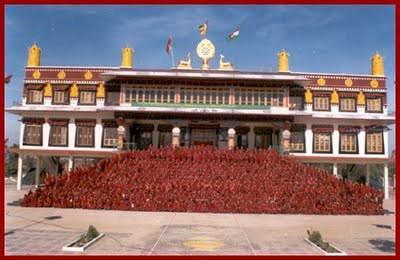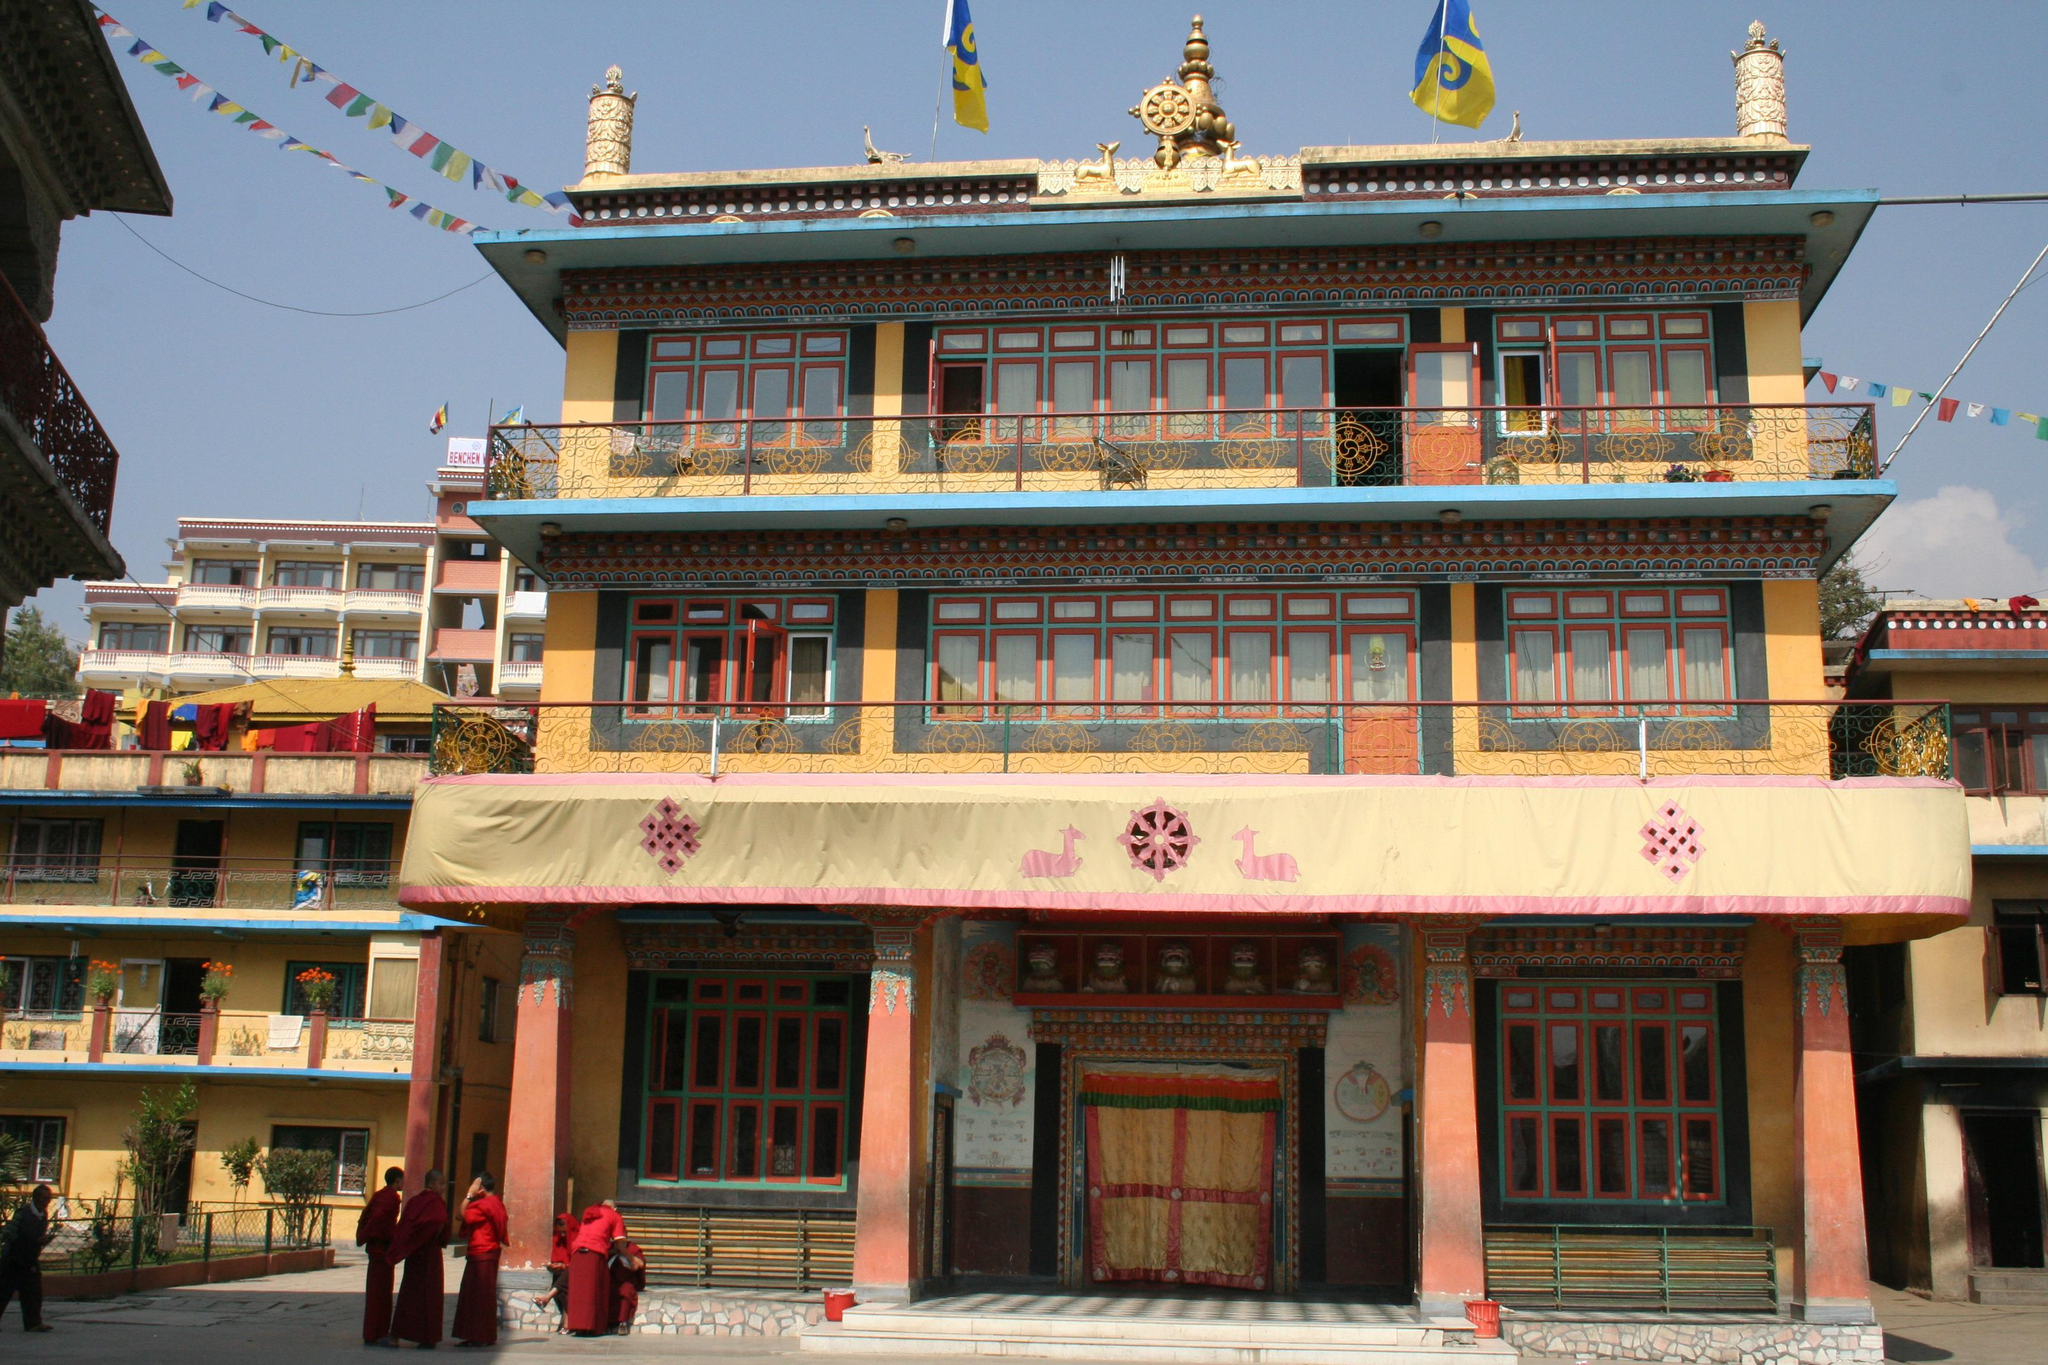The first image is the image on the left, the second image is the image on the right. Assess this claim about the two images: "The left and right image contains the same number of floors in the building.". Correct or not? Answer yes or no. Yes. The first image is the image on the left, the second image is the image on the right. For the images shown, is this caption "Both buildings have flat roofs with no curves on the sides." true? Answer yes or no. Yes. 